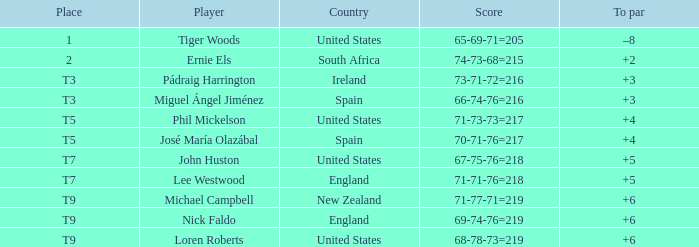In which country is the location "t9" associated with the player "michael campbell"? New Zealand. 